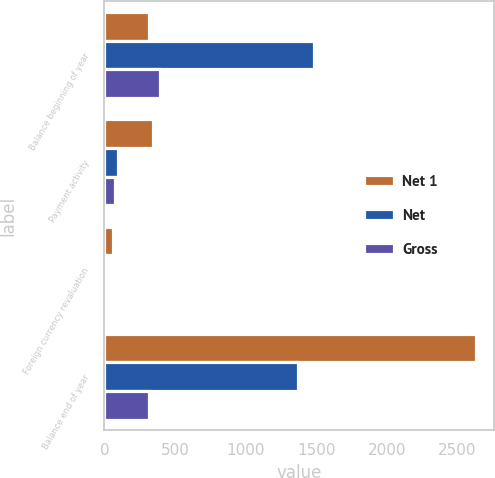Convert chart to OTSL. <chart><loc_0><loc_0><loc_500><loc_500><stacked_bar_chart><ecel><fcel>Balance beginning of year<fcel>Payment activity<fcel>Foreign currency revaluation<fcel>Balance end of year<nl><fcel>Net 1<fcel>314<fcel>347<fcel>63<fcel>2629<nl><fcel>Net<fcel>1482<fcel>99<fcel>16<fcel>1369<nl><fcel>Gross<fcel>393<fcel>75<fcel>2<fcel>314<nl></chart> 